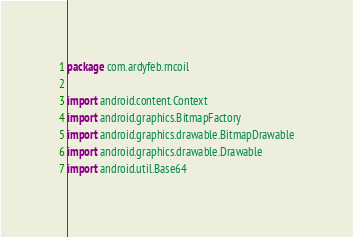Convert code to text. <code><loc_0><loc_0><loc_500><loc_500><_Kotlin_>package com.ardyfeb.rncoil

import android.content.Context
import android.graphics.BitmapFactory
import android.graphics.drawable.BitmapDrawable
import android.graphics.drawable.Drawable
import android.util.Base64
</code> 